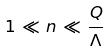Convert formula to latex. <formula><loc_0><loc_0><loc_500><loc_500>1 \, \ll \, n \, \ll \, \frac { Q } { \Lambda }</formula> 